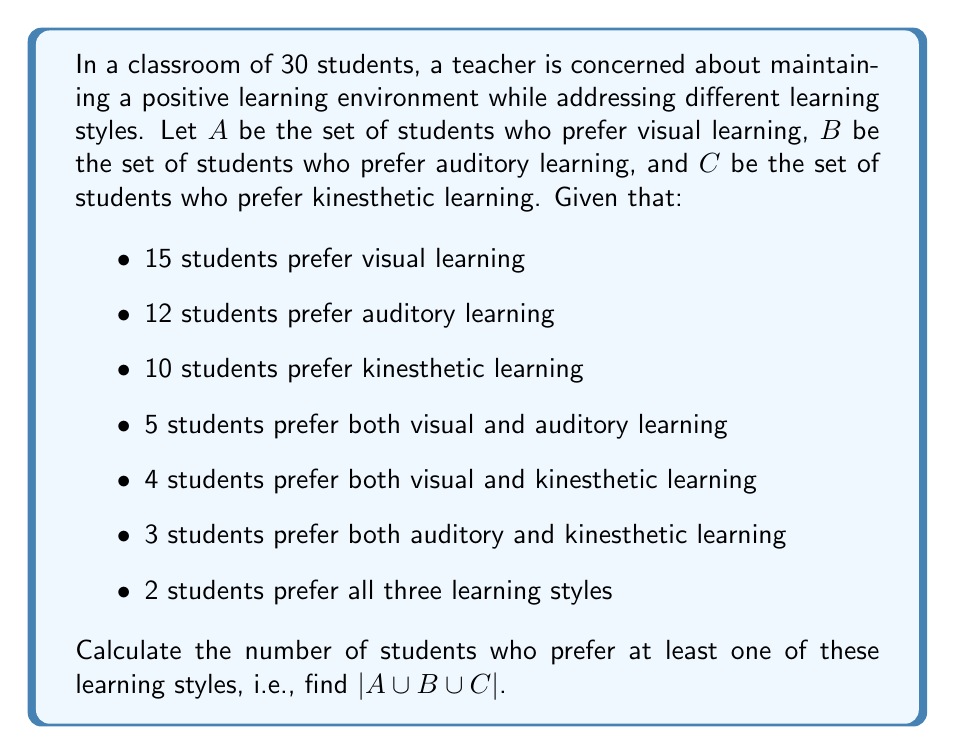Give your solution to this math problem. To solve this problem, we'll use the principle of inclusion-exclusion for three sets:

$$|A \cup B \cup C| = |A| + |B| + |C| - |A \cap B| - |A \cap C| - |B \cap C| + |A \cap B \cap C|$$

We're given:
$|A| = 15$, $|B| = 12$, $|C| = 10$
$|A \cap B| = 5$, $|A \cap C| = 4$, $|B \cap C| = 3$
$|A \cap B \cap C| = 2$

Substituting these values into the formula:

$$|A \cup B \cup C| = 15 + 12 + 10 - 5 - 4 - 3 + 2$$

Simplifying:
$$|A \cup B \cup C| = 37 - 12 + 2 = 27$$

Therefore, 27 students prefer at least one of these learning styles.

This approach allows the teacher to understand the diversity of learning preferences in the classroom without compromising the learning environment or turning the school into a fortress-like setting.
Answer: 27 students 